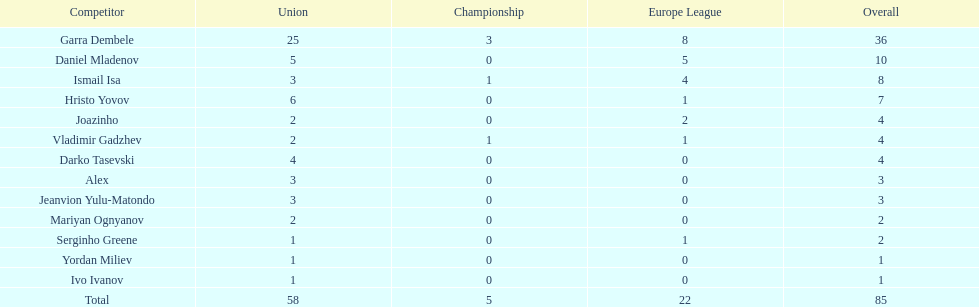What league is 2? 2, 2, 2. Which cup is less than 1? 0, 0. Which total is 2? 2. Who is the player? Mariyan Ognyanov. 